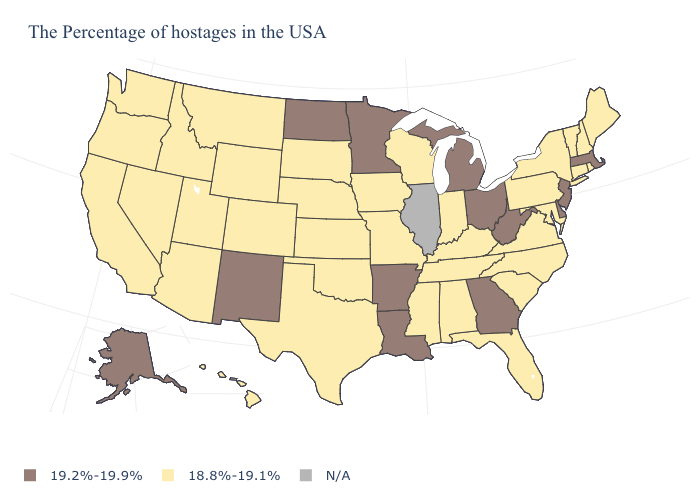Does Delaware have the highest value in the USA?
Write a very short answer. Yes. Which states have the lowest value in the USA?
Answer briefly. Maine, Rhode Island, New Hampshire, Vermont, Connecticut, New York, Maryland, Pennsylvania, Virginia, North Carolina, South Carolina, Florida, Kentucky, Indiana, Alabama, Tennessee, Wisconsin, Mississippi, Missouri, Iowa, Kansas, Nebraska, Oklahoma, Texas, South Dakota, Wyoming, Colorado, Utah, Montana, Arizona, Idaho, Nevada, California, Washington, Oregon, Hawaii. What is the lowest value in the USA?
Be succinct. 18.8%-19.1%. Name the states that have a value in the range 18.8%-19.1%?
Give a very brief answer. Maine, Rhode Island, New Hampshire, Vermont, Connecticut, New York, Maryland, Pennsylvania, Virginia, North Carolina, South Carolina, Florida, Kentucky, Indiana, Alabama, Tennessee, Wisconsin, Mississippi, Missouri, Iowa, Kansas, Nebraska, Oklahoma, Texas, South Dakota, Wyoming, Colorado, Utah, Montana, Arizona, Idaho, Nevada, California, Washington, Oregon, Hawaii. Among the states that border Utah , which have the lowest value?
Keep it brief. Wyoming, Colorado, Arizona, Idaho, Nevada. Which states have the lowest value in the USA?
Quick response, please. Maine, Rhode Island, New Hampshire, Vermont, Connecticut, New York, Maryland, Pennsylvania, Virginia, North Carolina, South Carolina, Florida, Kentucky, Indiana, Alabama, Tennessee, Wisconsin, Mississippi, Missouri, Iowa, Kansas, Nebraska, Oklahoma, Texas, South Dakota, Wyoming, Colorado, Utah, Montana, Arizona, Idaho, Nevada, California, Washington, Oregon, Hawaii. What is the highest value in states that border Kansas?
Keep it brief. 18.8%-19.1%. Which states have the highest value in the USA?
Short answer required. Massachusetts, New Jersey, Delaware, West Virginia, Ohio, Georgia, Michigan, Louisiana, Arkansas, Minnesota, North Dakota, New Mexico, Alaska. What is the lowest value in states that border Michigan?
Write a very short answer. 18.8%-19.1%. What is the value of New Jersey?
Answer briefly. 19.2%-19.9%. Name the states that have a value in the range 18.8%-19.1%?
Answer briefly. Maine, Rhode Island, New Hampshire, Vermont, Connecticut, New York, Maryland, Pennsylvania, Virginia, North Carolina, South Carolina, Florida, Kentucky, Indiana, Alabama, Tennessee, Wisconsin, Mississippi, Missouri, Iowa, Kansas, Nebraska, Oklahoma, Texas, South Dakota, Wyoming, Colorado, Utah, Montana, Arizona, Idaho, Nevada, California, Washington, Oregon, Hawaii. What is the value of Iowa?
Write a very short answer. 18.8%-19.1%. What is the value of Louisiana?
Write a very short answer. 19.2%-19.9%. 